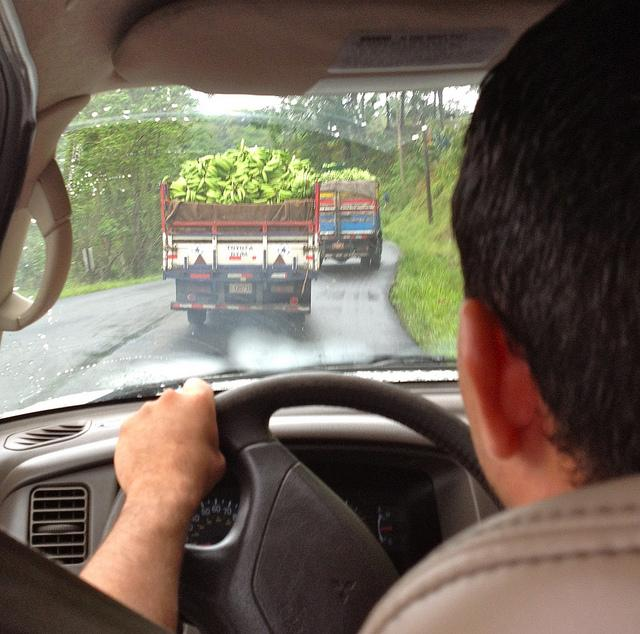What are the chances that at least one banana will fall out of the truck? Please explain your reasoning. high. There is a high chances that the banana feels easily. 